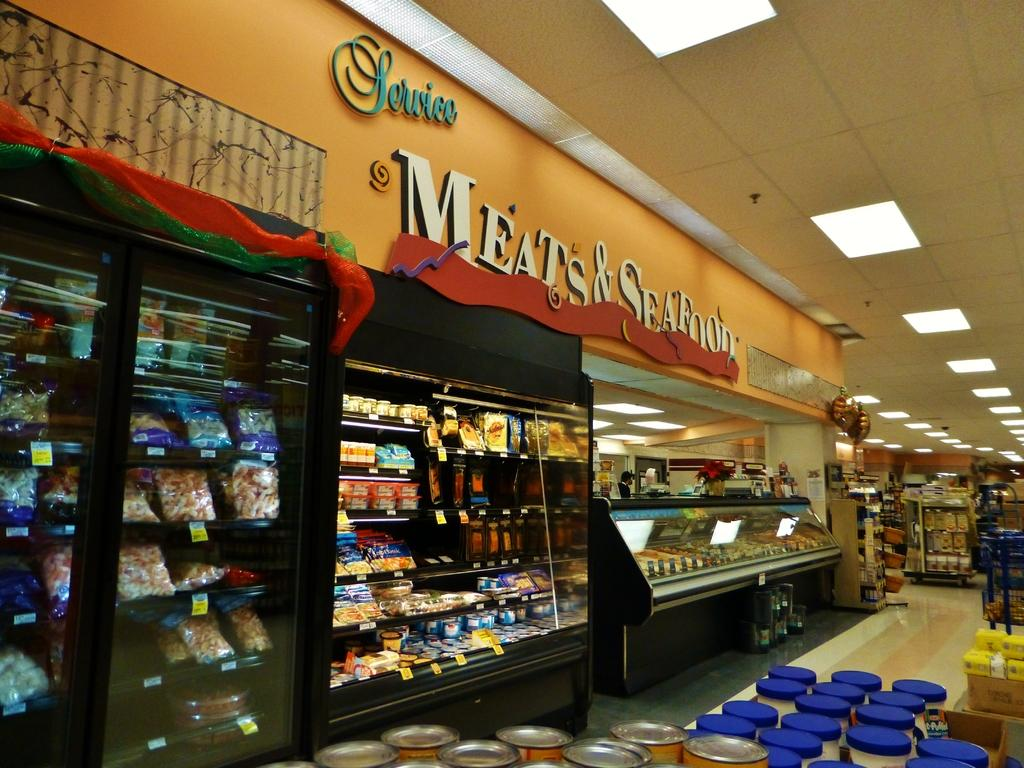<image>
Write a terse but informative summary of the picture. The meat and seafood section at a grocery store. 